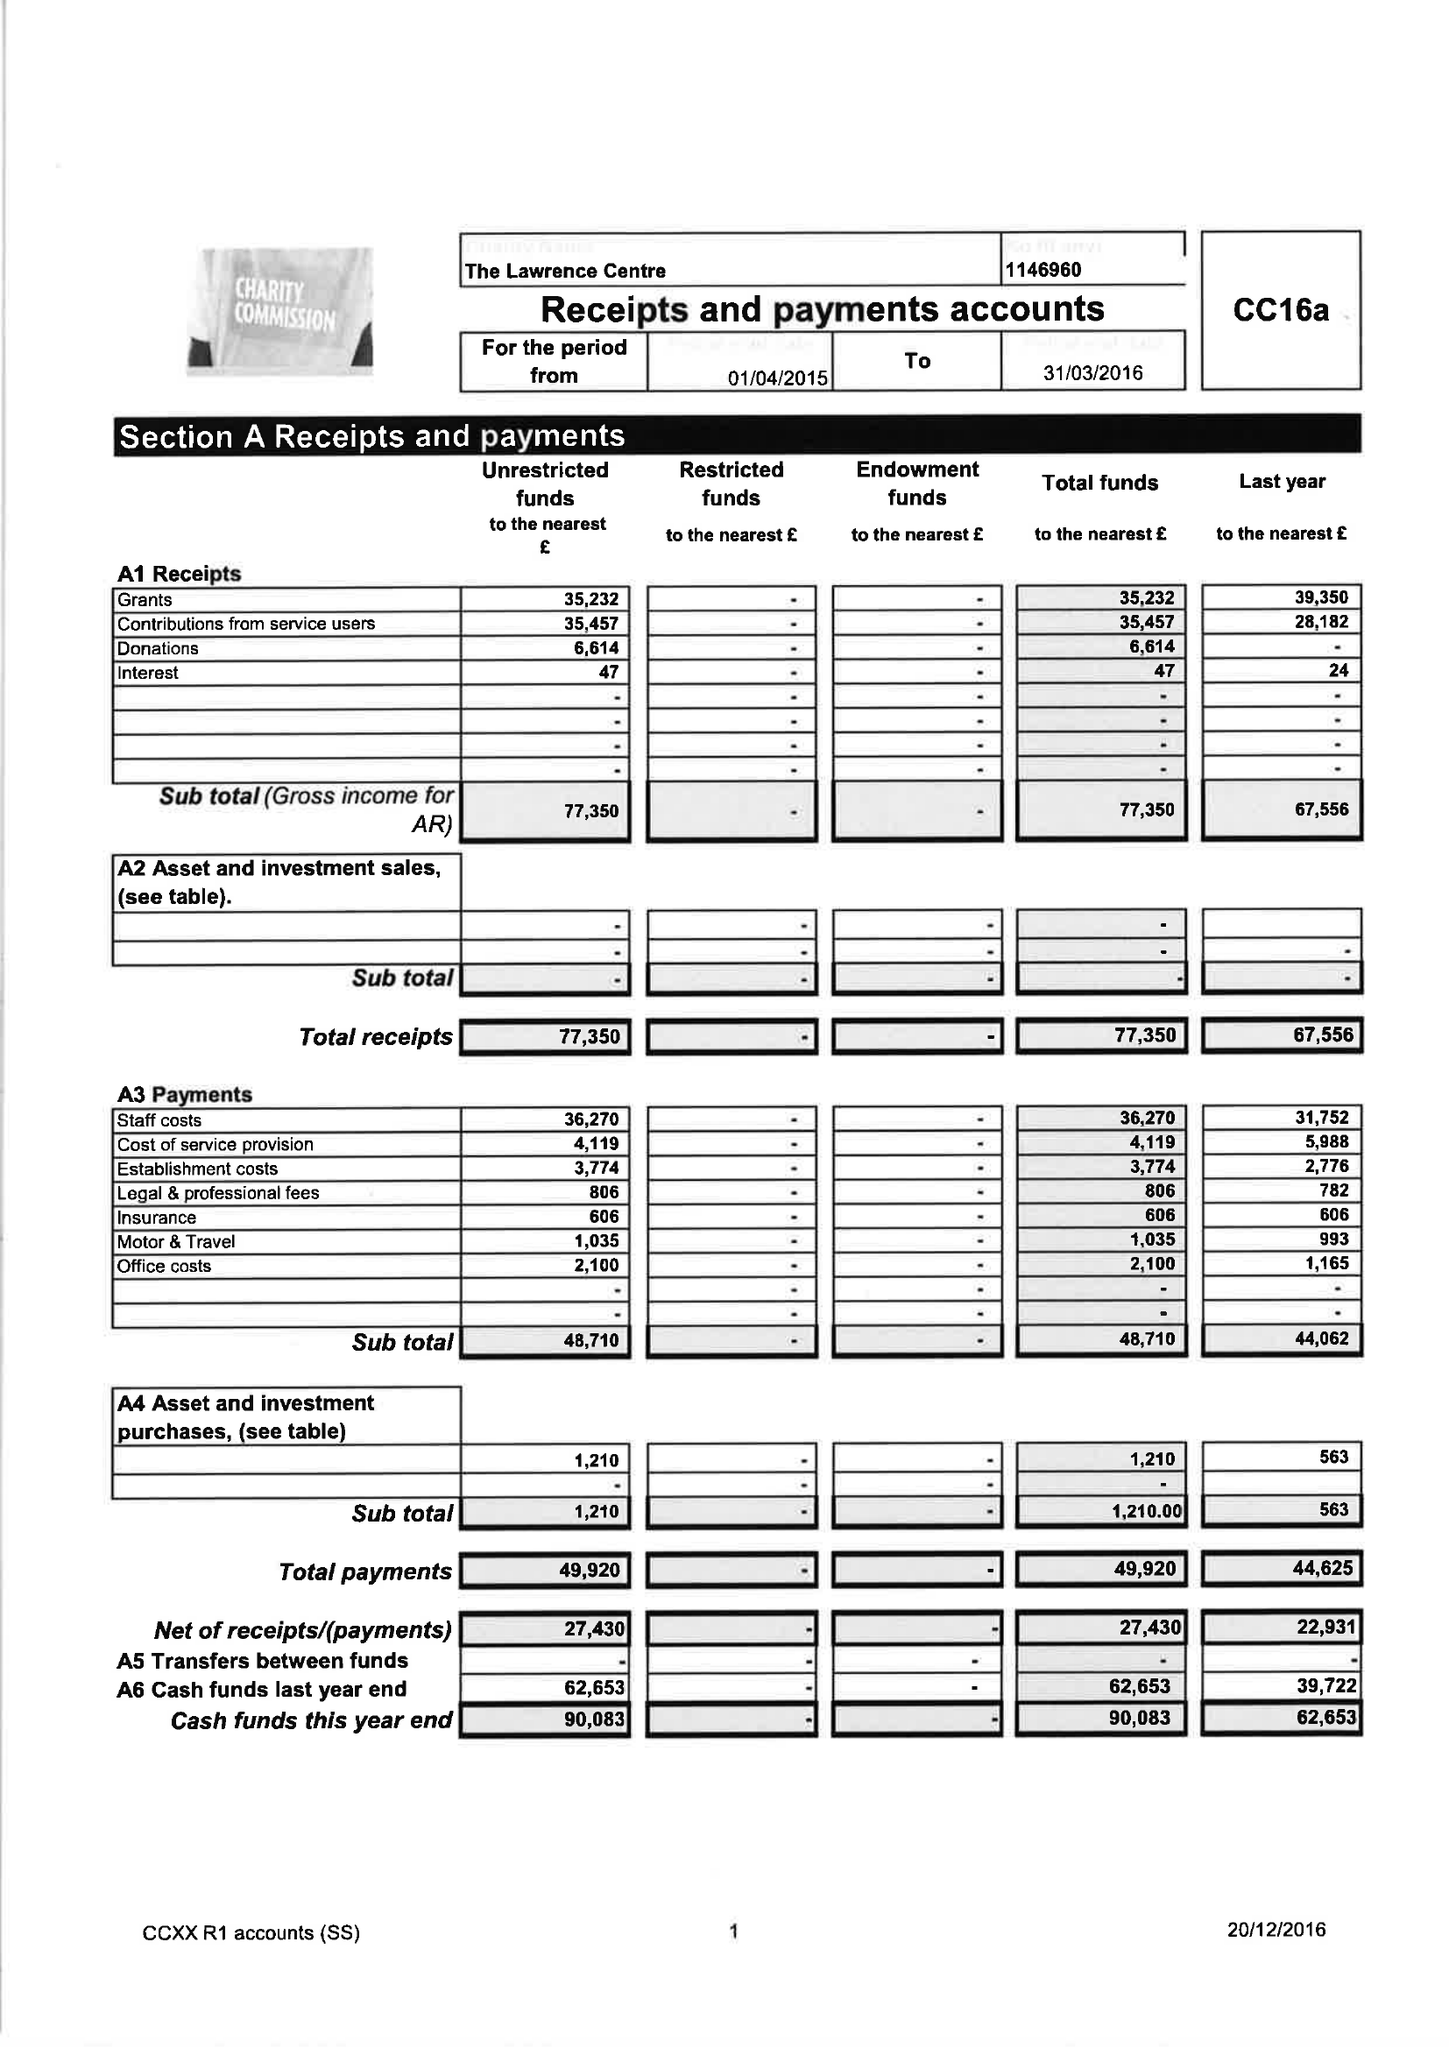What is the value for the charity_name?
Answer the question using a single word or phrase. The Lawrence Centre 